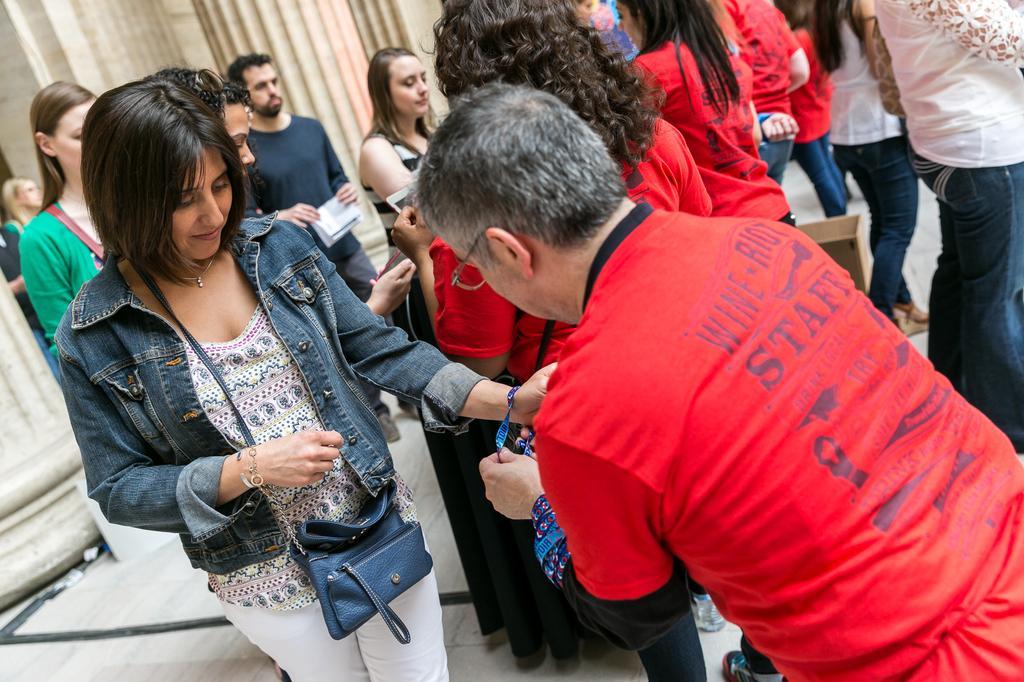In one or two sentences, can you explain what this image depicts? In this image we can see many people. There is a person wearing specs. He is holding something and tying on the hand of a lady. And the lady is wearing a bag. In the background there are pillars. 